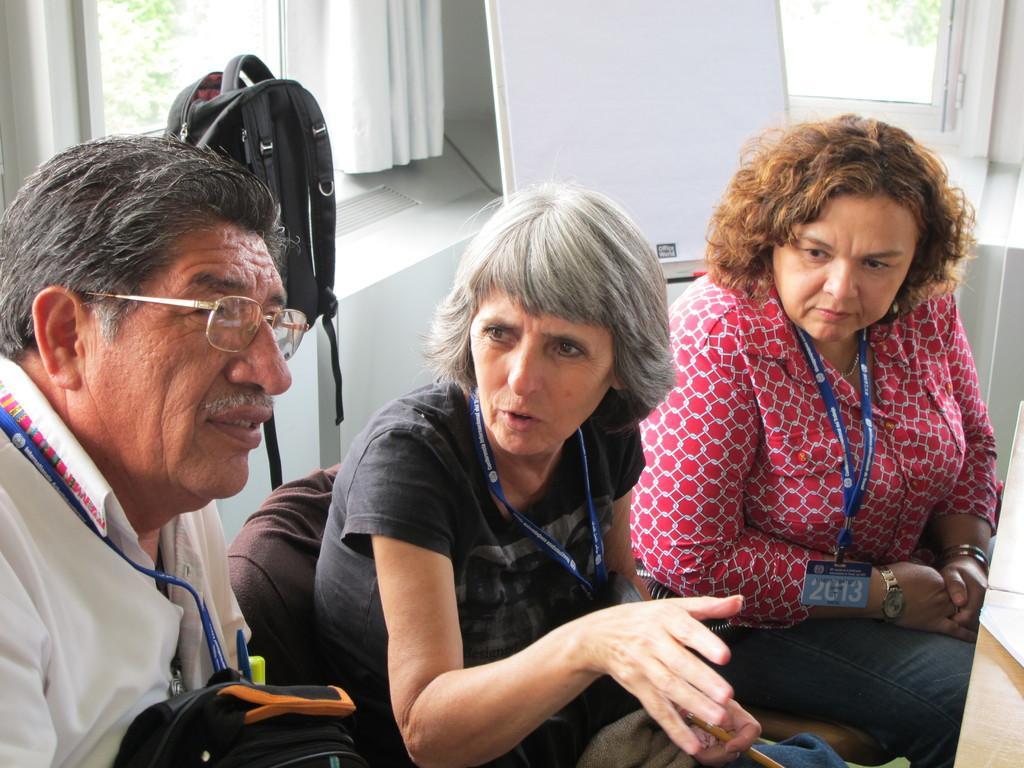Describe this image in one or two sentences. In this picture we can see bags, three people wore ID Cards and sitting on a chair. In the background we can see a board, curtain, windows and leaves. 